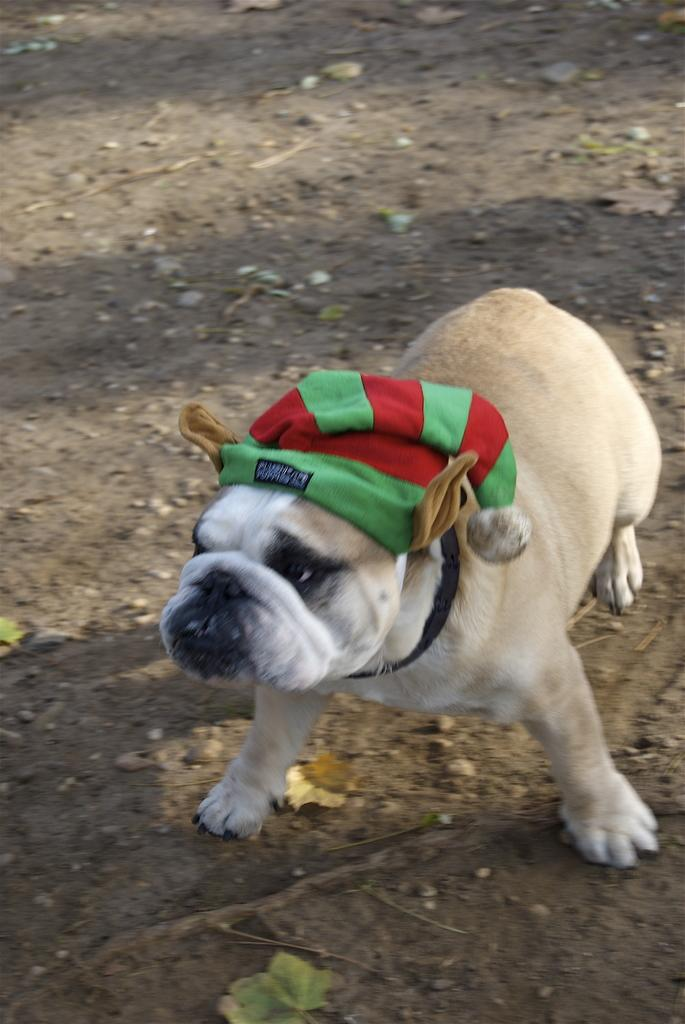What type of animal can be seen in the image? There is a dog in the image. What is at the bottom of the image? There is soil at the bottom of the image. What other objects are present in the image? There are stones in the image. What type of accessory is visible in the image? There is a cap visible in the image. What type of argument is taking place between the dog and the army in the image? There is no argument or army present in the image; it features a dog, soil, stones, and a cap. What type of pen is being used by the dog to write in the image? There is no pen present in the image, and dogs do not have the ability to write. 